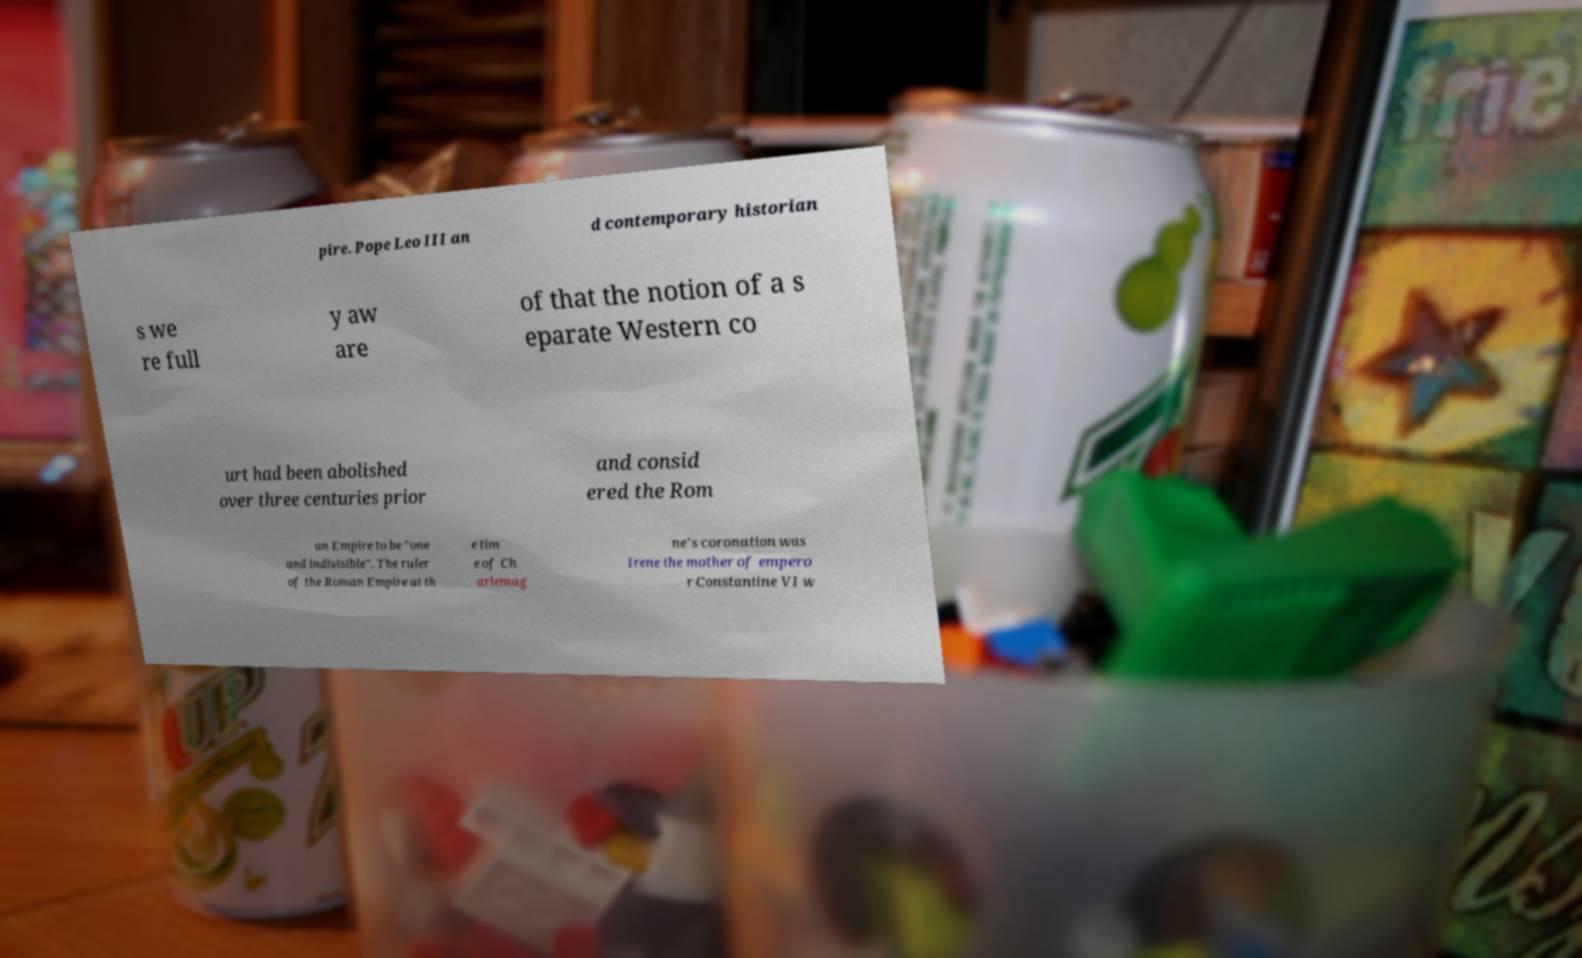Please read and relay the text visible in this image. What does it say? pire. Pope Leo III an d contemporary historian s we re full y aw are of that the notion of a s eparate Western co urt had been abolished over three centuries prior and consid ered the Rom an Empire to be "one and indivisible". The ruler of the Roman Empire at th e tim e of Ch arlemag ne's coronation was Irene the mother of empero r Constantine VI w 